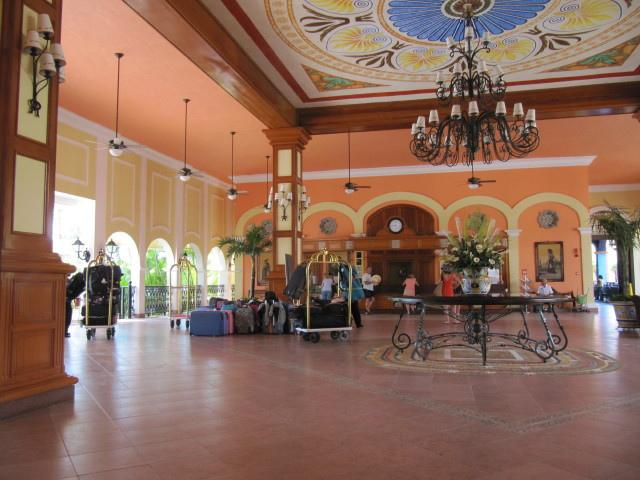What staff member is responsible for pushing the suitcase carts?

Choices:
A) bellhop
B) manager
C) janitor
D) maid bellhop 